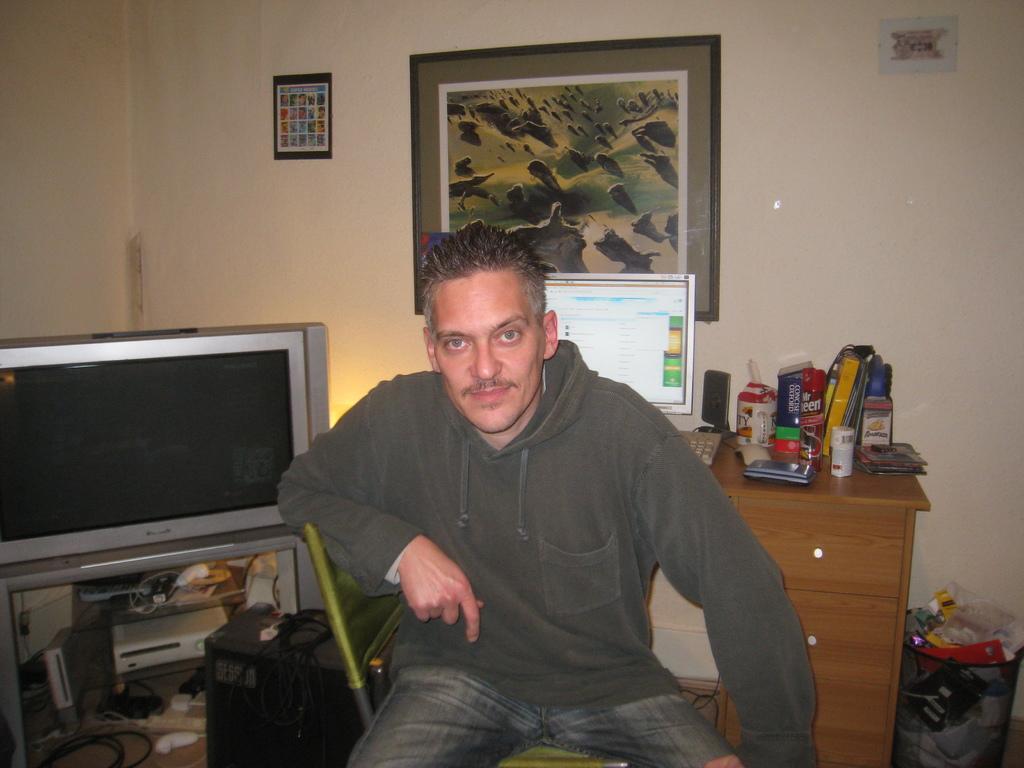Describe this image in one or two sentences. In this image there is a person sitting on chair. Left of it there is a television under which electronic items are kept. Backside to this person there is a table having monitor, keyboard, sound speaker, books on it. There is a picture frame fixed to the wall. 